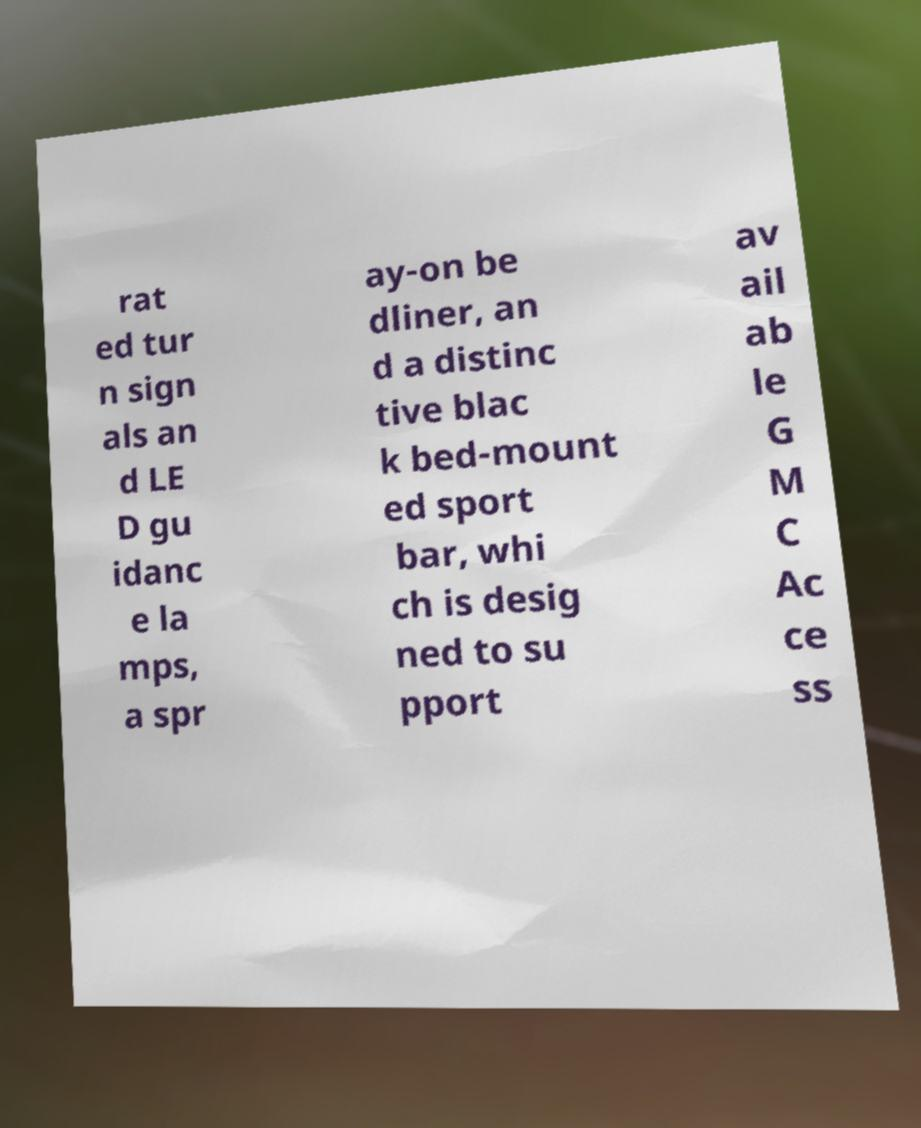Can you accurately transcribe the text from the provided image for me? rat ed tur n sign als an d LE D gu idanc e la mps, a spr ay-on be dliner, an d a distinc tive blac k bed-mount ed sport bar, whi ch is desig ned to su pport av ail ab le G M C Ac ce ss 